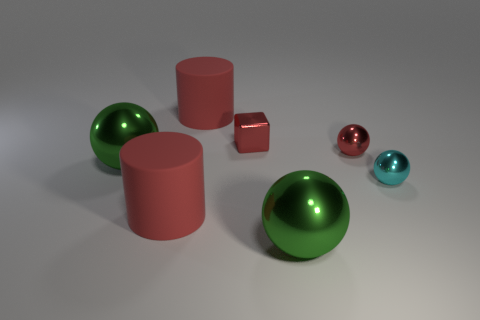Is the number of cyan shiny objects that are behind the cyan metal object less than the number of green metal cylinders?
Give a very brief answer. No. What material is the cylinder that is behind the big red object that is in front of the cyan object?
Give a very brief answer. Rubber. The object that is both to the right of the tiny red metal cube and in front of the small cyan ball has what shape?
Your answer should be compact. Sphere. What number of other things are there of the same color as the tiny block?
Provide a succinct answer. 3. How many objects are big rubber objects in front of the small cyan shiny ball or tiny cyan metal balls?
Make the answer very short. 2. Does the block have the same color as the big object that is to the right of the cube?
Provide a succinct answer. No. Is there anything else that is the same size as the red shiny sphere?
Your answer should be very brief. Yes. What is the size of the red cylinder in front of the large red matte object behind the tiny red cube?
Make the answer very short. Large. What number of things are either big cylinders or objects in front of the cyan shiny thing?
Offer a very short reply. 3. Do the green metal object that is right of the tiny metallic block and the cyan metallic thing have the same shape?
Offer a very short reply. Yes. 